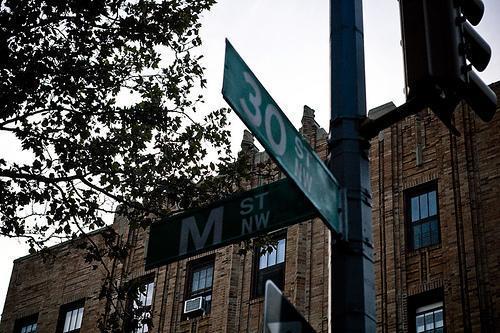How many windows can you see?
Give a very brief answer. 7. How many people are wearing skis in this image?
Give a very brief answer. 0. 